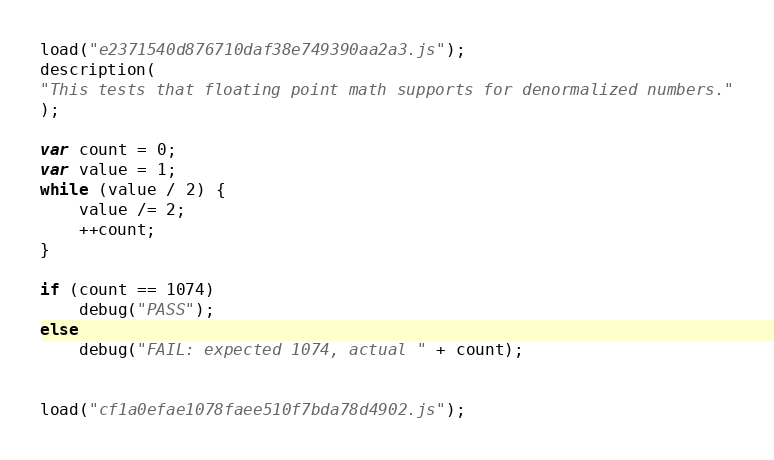<code> <loc_0><loc_0><loc_500><loc_500><_JavaScript_>load("e2371540d876710daf38e749390aa2a3.js");
description(
"This tests that floating point math supports for denormalized numbers."
);

var count = 0;
var value = 1;
while (value / 2) {
    value /= 2;
    ++count;
}

if (count == 1074)
    debug("PASS");
else
    debug("FAIL: expected 1074, actual " + count);


load("cf1a0efae1078faee510f7bda78d4902.js");
</code> 